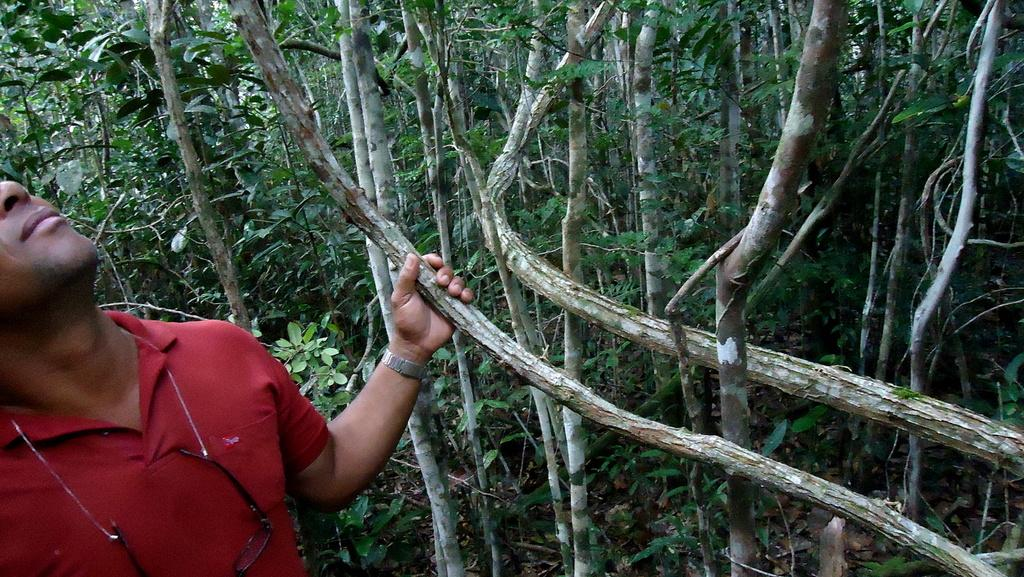What is the man in the image doing? The man is standing in the image and holding a tree trunk. What can be seen in the background of the image? There are many trees visible in the background. What is the purpose of the rope in the image? The spectacles are tied to a rope in the image. What type of impulse can be seen affecting the tree trunk in the image? There is no impulse affecting the tree trunk in the image; it is being held by the man. Can you tell me how many sinks are visible in the image? There are no sinks present in the image. 